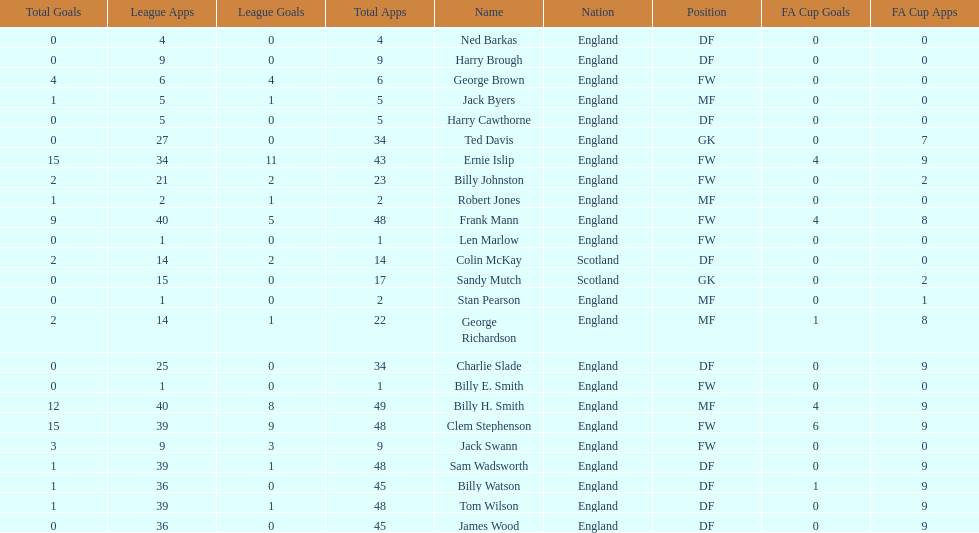How many players are fws? 8. 